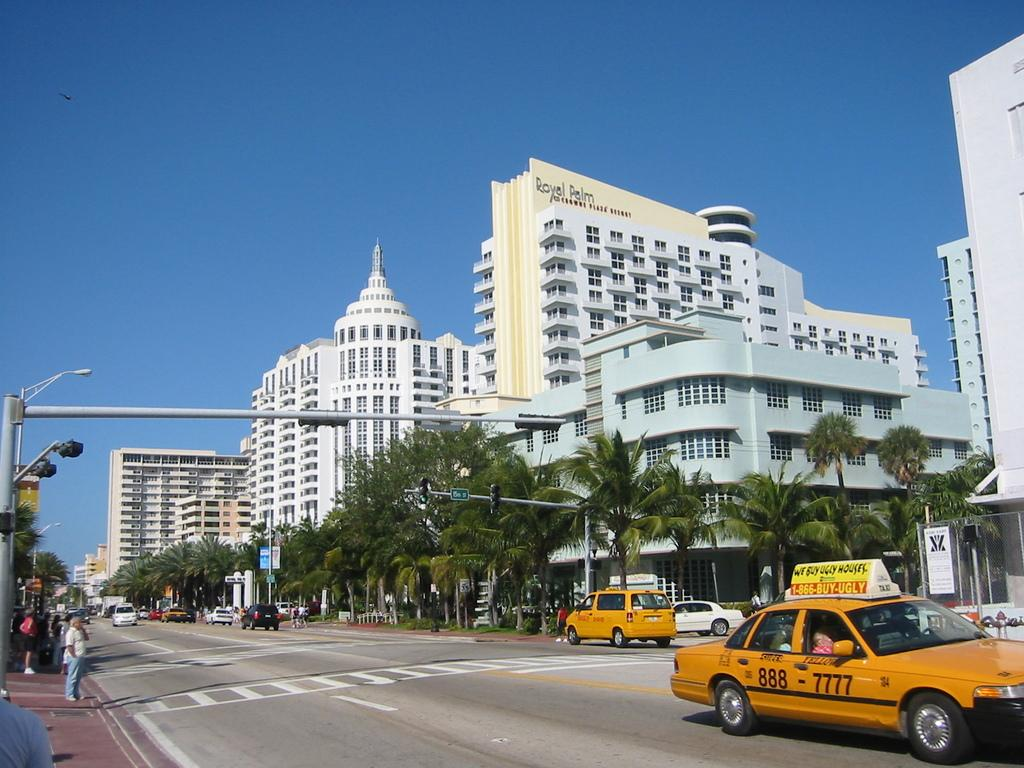<image>
Give a short and clear explanation of the subsequent image. The yellow building with the words Royal Palm at the top of it. 